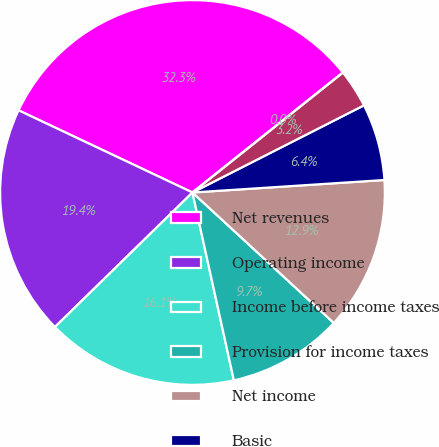Convert chart. <chart><loc_0><loc_0><loc_500><loc_500><pie_chart><fcel>Net revenues<fcel>Operating income<fcel>Income before income taxes<fcel>Provision for income taxes<fcel>Net income<fcel>Basic<fcel>Diluted<fcel>Cash dividends per common<nl><fcel>32.26%<fcel>19.35%<fcel>16.13%<fcel>9.68%<fcel>12.9%<fcel>6.45%<fcel>3.23%<fcel>0.0%<nl></chart> 